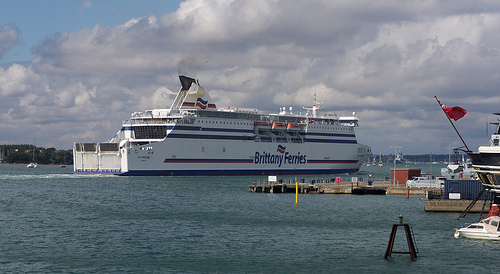Please provide a short description for this region: [0.5, 0.53, 0.62, 0.56]. Text on the white side of the ship reading 'Brittany Ferries' in blue. 